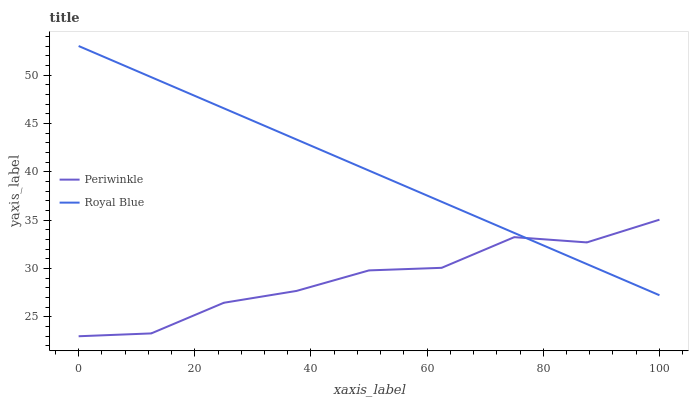Does Periwinkle have the maximum area under the curve?
Answer yes or no. No. Is Periwinkle the smoothest?
Answer yes or no. No. Does Periwinkle have the highest value?
Answer yes or no. No. 